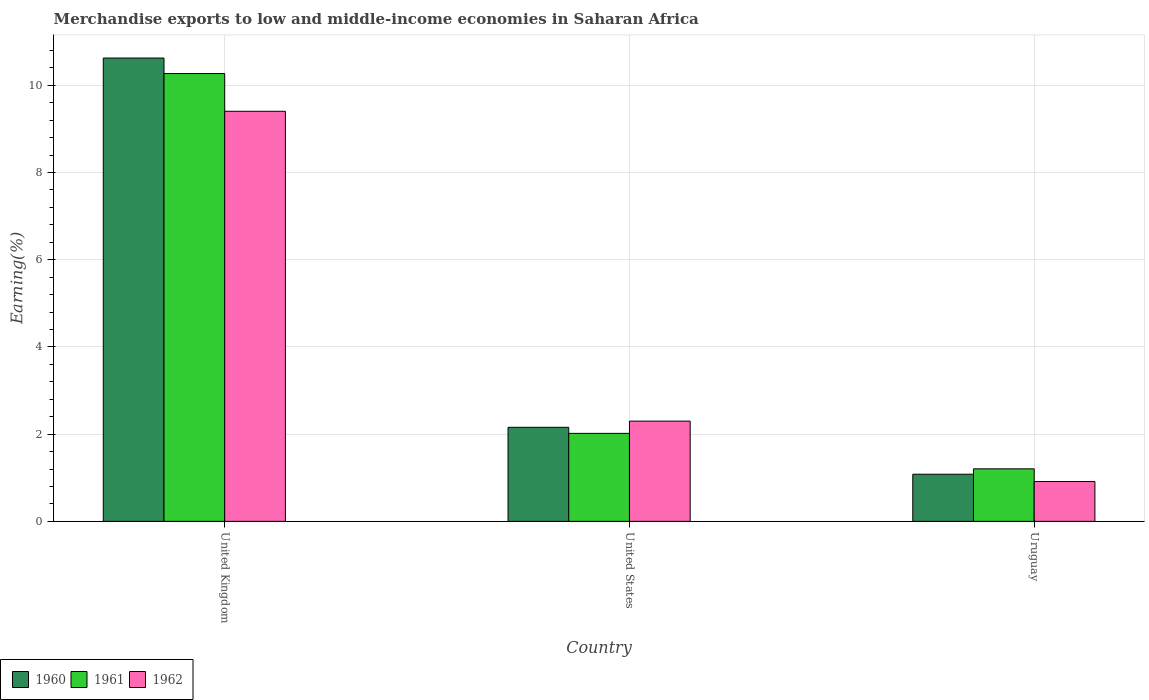How many different coloured bars are there?
Your answer should be very brief. 3. Are the number of bars per tick equal to the number of legend labels?
Provide a short and direct response. Yes. Are the number of bars on each tick of the X-axis equal?
Keep it short and to the point. Yes. How many bars are there on the 1st tick from the left?
Provide a succinct answer. 3. How many bars are there on the 2nd tick from the right?
Your answer should be very brief. 3. What is the label of the 2nd group of bars from the left?
Offer a very short reply. United States. In how many cases, is the number of bars for a given country not equal to the number of legend labels?
Provide a succinct answer. 0. What is the percentage of amount earned from merchandise exports in 1962 in United States?
Keep it short and to the point. 2.3. Across all countries, what is the maximum percentage of amount earned from merchandise exports in 1961?
Give a very brief answer. 10.27. Across all countries, what is the minimum percentage of amount earned from merchandise exports in 1960?
Keep it short and to the point. 1.08. In which country was the percentage of amount earned from merchandise exports in 1960 maximum?
Give a very brief answer. United Kingdom. In which country was the percentage of amount earned from merchandise exports in 1961 minimum?
Your response must be concise. Uruguay. What is the total percentage of amount earned from merchandise exports in 1960 in the graph?
Provide a succinct answer. 13.86. What is the difference between the percentage of amount earned from merchandise exports in 1960 in United Kingdom and that in Uruguay?
Your response must be concise. 9.54. What is the difference between the percentage of amount earned from merchandise exports in 1960 in United Kingdom and the percentage of amount earned from merchandise exports in 1962 in Uruguay?
Provide a succinct answer. 9.71. What is the average percentage of amount earned from merchandise exports in 1961 per country?
Your answer should be compact. 4.5. What is the difference between the percentage of amount earned from merchandise exports of/in 1960 and percentage of amount earned from merchandise exports of/in 1962 in United Kingdom?
Your answer should be very brief. 1.22. In how many countries, is the percentage of amount earned from merchandise exports in 1960 greater than 5.2 %?
Provide a short and direct response. 1. What is the ratio of the percentage of amount earned from merchandise exports in 1962 in United Kingdom to that in United States?
Ensure brevity in your answer.  4.09. Is the difference between the percentage of amount earned from merchandise exports in 1960 in United Kingdom and Uruguay greater than the difference between the percentage of amount earned from merchandise exports in 1962 in United Kingdom and Uruguay?
Provide a succinct answer. Yes. What is the difference between the highest and the second highest percentage of amount earned from merchandise exports in 1962?
Keep it short and to the point. -8.49. What is the difference between the highest and the lowest percentage of amount earned from merchandise exports in 1961?
Ensure brevity in your answer.  9.07. In how many countries, is the percentage of amount earned from merchandise exports in 1962 greater than the average percentage of amount earned from merchandise exports in 1962 taken over all countries?
Make the answer very short. 1. What does the 2nd bar from the left in United States represents?
Your answer should be very brief. 1961. Is it the case that in every country, the sum of the percentage of amount earned from merchandise exports in 1962 and percentage of amount earned from merchandise exports in 1960 is greater than the percentage of amount earned from merchandise exports in 1961?
Provide a short and direct response. Yes. Does the graph contain any zero values?
Offer a terse response. No. Does the graph contain grids?
Give a very brief answer. Yes. How many legend labels are there?
Your answer should be very brief. 3. What is the title of the graph?
Keep it short and to the point. Merchandise exports to low and middle-income economies in Saharan Africa. Does "1983" appear as one of the legend labels in the graph?
Ensure brevity in your answer.  No. What is the label or title of the X-axis?
Offer a very short reply. Country. What is the label or title of the Y-axis?
Your answer should be very brief. Earning(%). What is the Earning(%) in 1960 in United Kingdom?
Offer a terse response. 10.63. What is the Earning(%) in 1961 in United Kingdom?
Provide a succinct answer. 10.27. What is the Earning(%) of 1962 in United Kingdom?
Your answer should be compact. 9.4. What is the Earning(%) in 1960 in United States?
Provide a short and direct response. 2.16. What is the Earning(%) of 1961 in United States?
Make the answer very short. 2.02. What is the Earning(%) in 1962 in United States?
Make the answer very short. 2.3. What is the Earning(%) of 1960 in Uruguay?
Provide a succinct answer. 1.08. What is the Earning(%) of 1961 in Uruguay?
Provide a succinct answer. 1.2. What is the Earning(%) in 1962 in Uruguay?
Your answer should be very brief. 0.91. Across all countries, what is the maximum Earning(%) in 1960?
Make the answer very short. 10.63. Across all countries, what is the maximum Earning(%) in 1961?
Give a very brief answer. 10.27. Across all countries, what is the maximum Earning(%) of 1962?
Offer a terse response. 9.4. Across all countries, what is the minimum Earning(%) of 1960?
Make the answer very short. 1.08. Across all countries, what is the minimum Earning(%) in 1961?
Your answer should be very brief. 1.2. Across all countries, what is the minimum Earning(%) in 1962?
Your answer should be compact. 0.91. What is the total Earning(%) in 1960 in the graph?
Your answer should be very brief. 13.86. What is the total Earning(%) of 1961 in the graph?
Provide a succinct answer. 13.49. What is the total Earning(%) of 1962 in the graph?
Offer a terse response. 12.62. What is the difference between the Earning(%) of 1960 in United Kingdom and that in United States?
Your response must be concise. 8.47. What is the difference between the Earning(%) of 1961 in United Kingdom and that in United States?
Keep it short and to the point. 8.25. What is the difference between the Earning(%) in 1962 in United Kingdom and that in United States?
Your answer should be compact. 7.11. What is the difference between the Earning(%) in 1960 in United Kingdom and that in Uruguay?
Your response must be concise. 9.54. What is the difference between the Earning(%) of 1961 in United Kingdom and that in Uruguay?
Ensure brevity in your answer.  9.07. What is the difference between the Earning(%) of 1962 in United Kingdom and that in Uruguay?
Ensure brevity in your answer.  8.49. What is the difference between the Earning(%) of 1960 in United States and that in Uruguay?
Provide a short and direct response. 1.08. What is the difference between the Earning(%) of 1961 in United States and that in Uruguay?
Your response must be concise. 0.81. What is the difference between the Earning(%) of 1962 in United States and that in Uruguay?
Provide a short and direct response. 1.39. What is the difference between the Earning(%) of 1960 in United Kingdom and the Earning(%) of 1961 in United States?
Provide a succinct answer. 8.61. What is the difference between the Earning(%) in 1960 in United Kingdom and the Earning(%) in 1962 in United States?
Give a very brief answer. 8.33. What is the difference between the Earning(%) of 1961 in United Kingdom and the Earning(%) of 1962 in United States?
Your answer should be compact. 7.97. What is the difference between the Earning(%) of 1960 in United Kingdom and the Earning(%) of 1961 in Uruguay?
Ensure brevity in your answer.  9.42. What is the difference between the Earning(%) of 1960 in United Kingdom and the Earning(%) of 1962 in Uruguay?
Keep it short and to the point. 9.71. What is the difference between the Earning(%) in 1961 in United Kingdom and the Earning(%) in 1962 in Uruguay?
Your answer should be compact. 9.36. What is the difference between the Earning(%) in 1960 in United States and the Earning(%) in 1961 in Uruguay?
Keep it short and to the point. 0.95. What is the difference between the Earning(%) of 1960 in United States and the Earning(%) of 1962 in Uruguay?
Ensure brevity in your answer.  1.24. What is the difference between the Earning(%) in 1961 in United States and the Earning(%) in 1962 in Uruguay?
Offer a terse response. 1.1. What is the average Earning(%) of 1960 per country?
Give a very brief answer. 4.62. What is the average Earning(%) in 1961 per country?
Provide a succinct answer. 4.5. What is the average Earning(%) in 1962 per country?
Ensure brevity in your answer.  4.21. What is the difference between the Earning(%) in 1960 and Earning(%) in 1961 in United Kingdom?
Ensure brevity in your answer.  0.36. What is the difference between the Earning(%) of 1960 and Earning(%) of 1962 in United Kingdom?
Offer a terse response. 1.22. What is the difference between the Earning(%) of 1961 and Earning(%) of 1962 in United Kingdom?
Offer a very short reply. 0.87. What is the difference between the Earning(%) of 1960 and Earning(%) of 1961 in United States?
Your answer should be compact. 0.14. What is the difference between the Earning(%) of 1960 and Earning(%) of 1962 in United States?
Your response must be concise. -0.14. What is the difference between the Earning(%) of 1961 and Earning(%) of 1962 in United States?
Keep it short and to the point. -0.28. What is the difference between the Earning(%) in 1960 and Earning(%) in 1961 in Uruguay?
Give a very brief answer. -0.12. What is the difference between the Earning(%) of 1960 and Earning(%) of 1962 in Uruguay?
Ensure brevity in your answer.  0.17. What is the difference between the Earning(%) in 1961 and Earning(%) in 1962 in Uruguay?
Make the answer very short. 0.29. What is the ratio of the Earning(%) in 1960 in United Kingdom to that in United States?
Offer a very short reply. 4.93. What is the ratio of the Earning(%) of 1961 in United Kingdom to that in United States?
Provide a succinct answer. 5.09. What is the ratio of the Earning(%) in 1962 in United Kingdom to that in United States?
Make the answer very short. 4.09. What is the ratio of the Earning(%) of 1960 in United Kingdom to that in Uruguay?
Keep it short and to the point. 9.83. What is the ratio of the Earning(%) of 1961 in United Kingdom to that in Uruguay?
Your response must be concise. 8.52. What is the ratio of the Earning(%) in 1962 in United Kingdom to that in Uruguay?
Your answer should be very brief. 10.3. What is the ratio of the Earning(%) of 1960 in United States to that in Uruguay?
Give a very brief answer. 2. What is the ratio of the Earning(%) of 1961 in United States to that in Uruguay?
Give a very brief answer. 1.68. What is the ratio of the Earning(%) of 1962 in United States to that in Uruguay?
Make the answer very short. 2.52. What is the difference between the highest and the second highest Earning(%) in 1960?
Keep it short and to the point. 8.47. What is the difference between the highest and the second highest Earning(%) in 1961?
Ensure brevity in your answer.  8.25. What is the difference between the highest and the second highest Earning(%) of 1962?
Your answer should be compact. 7.11. What is the difference between the highest and the lowest Earning(%) of 1960?
Your answer should be very brief. 9.54. What is the difference between the highest and the lowest Earning(%) of 1961?
Your answer should be very brief. 9.07. What is the difference between the highest and the lowest Earning(%) of 1962?
Give a very brief answer. 8.49. 